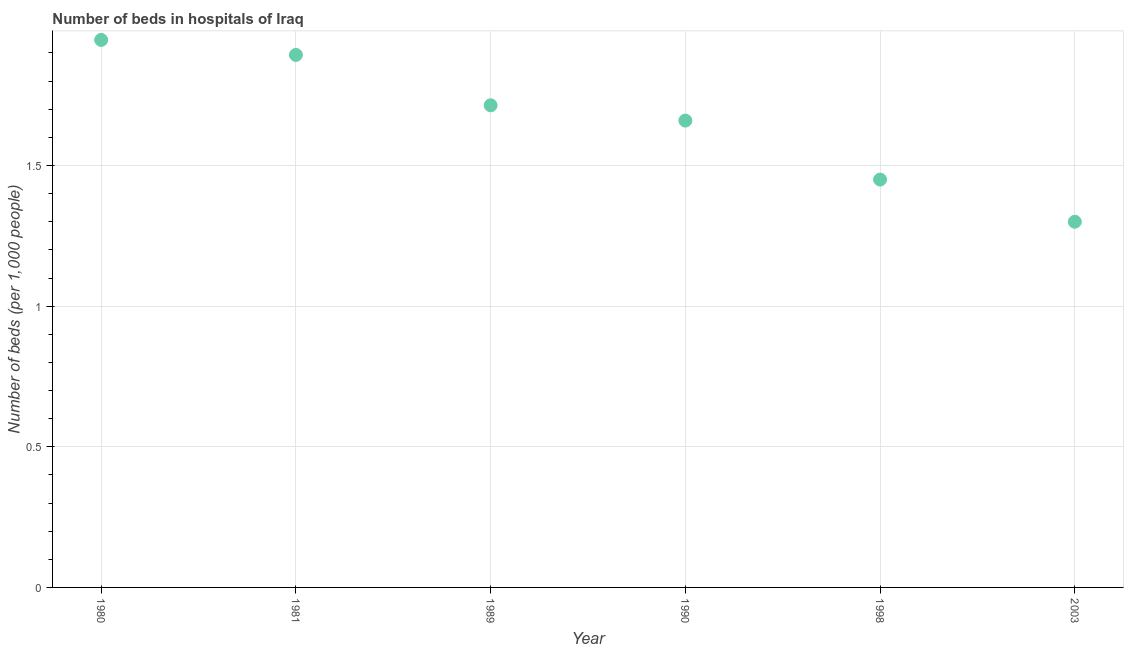What is the number of hospital beds in 1998?
Your response must be concise. 1.45. Across all years, what is the maximum number of hospital beds?
Provide a succinct answer. 1.95. Across all years, what is the minimum number of hospital beds?
Give a very brief answer. 1.3. In which year was the number of hospital beds minimum?
Offer a very short reply. 2003. What is the sum of the number of hospital beds?
Your response must be concise. 9.96. What is the difference between the number of hospital beds in 1981 and 1990?
Ensure brevity in your answer.  0.23. What is the average number of hospital beds per year?
Offer a terse response. 1.66. What is the median number of hospital beds?
Ensure brevity in your answer.  1.69. In how many years, is the number of hospital beds greater than 0.7 %?
Offer a terse response. 6. What is the ratio of the number of hospital beds in 1981 to that in 1990?
Your response must be concise. 1.14. Is the number of hospital beds in 1980 less than that in 2003?
Provide a succinct answer. No. What is the difference between the highest and the second highest number of hospital beds?
Provide a short and direct response. 0.05. Is the sum of the number of hospital beds in 1980 and 1989 greater than the maximum number of hospital beds across all years?
Provide a short and direct response. Yes. What is the difference between the highest and the lowest number of hospital beds?
Make the answer very short. 0.65. In how many years, is the number of hospital beds greater than the average number of hospital beds taken over all years?
Keep it short and to the point. 3. How many dotlines are there?
Keep it short and to the point. 1. How many years are there in the graph?
Give a very brief answer. 6. What is the difference between two consecutive major ticks on the Y-axis?
Keep it short and to the point. 0.5. Does the graph contain any zero values?
Make the answer very short. No. What is the title of the graph?
Provide a succinct answer. Number of beds in hospitals of Iraq. What is the label or title of the Y-axis?
Offer a terse response. Number of beds (per 1,0 people). What is the Number of beds (per 1,000 people) in 1980?
Ensure brevity in your answer.  1.95. What is the Number of beds (per 1,000 people) in 1981?
Provide a short and direct response. 1.89. What is the Number of beds (per 1,000 people) in 1989?
Provide a succinct answer. 1.71. What is the Number of beds (per 1,000 people) in 1990?
Your answer should be compact. 1.66. What is the Number of beds (per 1,000 people) in 1998?
Provide a succinct answer. 1.45. What is the Number of beds (per 1,000 people) in 2003?
Make the answer very short. 1.3. What is the difference between the Number of beds (per 1,000 people) in 1980 and 1981?
Your response must be concise. 0.05. What is the difference between the Number of beds (per 1,000 people) in 1980 and 1989?
Keep it short and to the point. 0.23. What is the difference between the Number of beds (per 1,000 people) in 1980 and 1990?
Provide a succinct answer. 0.29. What is the difference between the Number of beds (per 1,000 people) in 1980 and 1998?
Your answer should be compact. 0.5. What is the difference between the Number of beds (per 1,000 people) in 1980 and 2003?
Give a very brief answer. 0.65. What is the difference between the Number of beds (per 1,000 people) in 1981 and 1989?
Your response must be concise. 0.18. What is the difference between the Number of beds (per 1,000 people) in 1981 and 1990?
Keep it short and to the point. 0.23. What is the difference between the Number of beds (per 1,000 people) in 1981 and 1998?
Keep it short and to the point. 0.44. What is the difference between the Number of beds (per 1,000 people) in 1981 and 2003?
Your answer should be very brief. 0.59. What is the difference between the Number of beds (per 1,000 people) in 1989 and 1990?
Your answer should be very brief. 0.05. What is the difference between the Number of beds (per 1,000 people) in 1989 and 1998?
Your answer should be very brief. 0.26. What is the difference between the Number of beds (per 1,000 people) in 1989 and 2003?
Provide a short and direct response. 0.41. What is the difference between the Number of beds (per 1,000 people) in 1990 and 1998?
Your answer should be very brief. 0.21. What is the difference between the Number of beds (per 1,000 people) in 1990 and 2003?
Provide a short and direct response. 0.36. What is the ratio of the Number of beds (per 1,000 people) in 1980 to that in 1981?
Keep it short and to the point. 1.03. What is the ratio of the Number of beds (per 1,000 people) in 1980 to that in 1989?
Ensure brevity in your answer.  1.14. What is the ratio of the Number of beds (per 1,000 people) in 1980 to that in 1990?
Offer a terse response. 1.17. What is the ratio of the Number of beds (per 1,000 people) in 1980 to that in 1998?
Ensure brevity in your answer.  1.34. What is the ratio of the Number of beds (per 1,000 people) in 1980 to that in 2003?
Provide a short and direct response. 1.5. What is the ratio of the Number of beds (per 1,000 people) in 1981 to that in 1989?
Your answer should be very brief. 1.1. What is the ratio of the Number of beds (per 1,000 people) in 1981 to that in 1990?
Give a very brief answer. 1.14. What is the ratio of the Number of beds (per 1,000 people) in 1981 to that in 1998?
Offer a very short reply. 1.31. What is the ratio of the Number of beds (per 1,000 people) in 1981 to that in 2003?
Your answer should be very brief. 1.46. What is the ratio of the Number of beds (per 1,000 people) in 1989 to that in 1990?
Your answer should be very brief. 1.03. What is the ratio of the Number of beds (per 1,000 people) in 1989 to that in 1998?
Make the answer very short. 1.18. What is the ratio of the Number of beds (per 1,000 people) in 1989 to that in 2003?
Keep it short and to the point. 1.32. What is the ratio of the Number of beds (per 1,000 people) in 1990 to that in 1998?
Your response must be concise. 1.15. What is the ratio of the Number of beds (per 1,000 people) in 1990 to that in 2003?
Your answer should be compact. 1.28. What is the ratio of the Number of beds (per 1,000 people) in 1998 to that in 2003?
Ensure brevity in your answer.  1.11. 